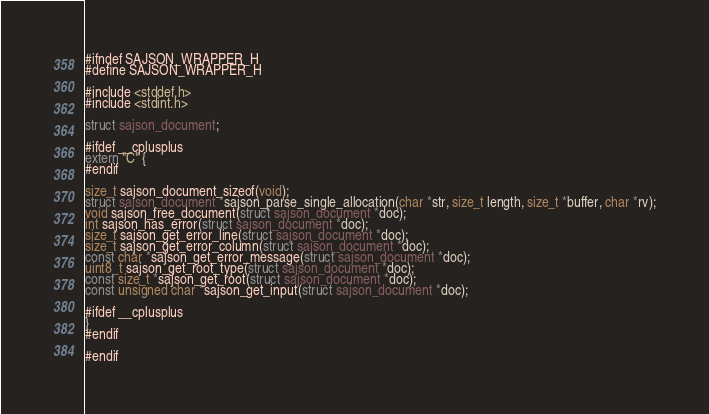<code> <loc_0><loc_0><loc_500><loc_500><_C_>#ifndef SAJSON_WRAPPER_H
#define SAJSON_WRAPPER_H

#include <stddef.h>
#include <stdint.h>

struct sajson_document;

#ifdef __cplusplus
extern "C" {
#endif

size_t sajson_document_sizeof(void);
struct sajson_document *sajson_parse_single_allocation(char *str, size_t length, size_t *buffer, char *rv);
void sajson_free_document(struct sajson_document *doc);
int sajson_has_error(struct sajson_document *doc);
size_t sajson_get_error_line(struct sajson_document *doc);
size_t sajson_get_error_column(struct sajson_document *doc);
const char *sajson_get_error_message(struct sajson_document *doc);
uint8_t sajson_get_root_type(struct sajson_document *doc);
const size_t *sajson_get_root(struct sajson_document *doc);
const unsigned char *sajson_get_input(struct sajson_document *doc);

#ifdef __cplusplus
}
#endif

#endif
</code> 